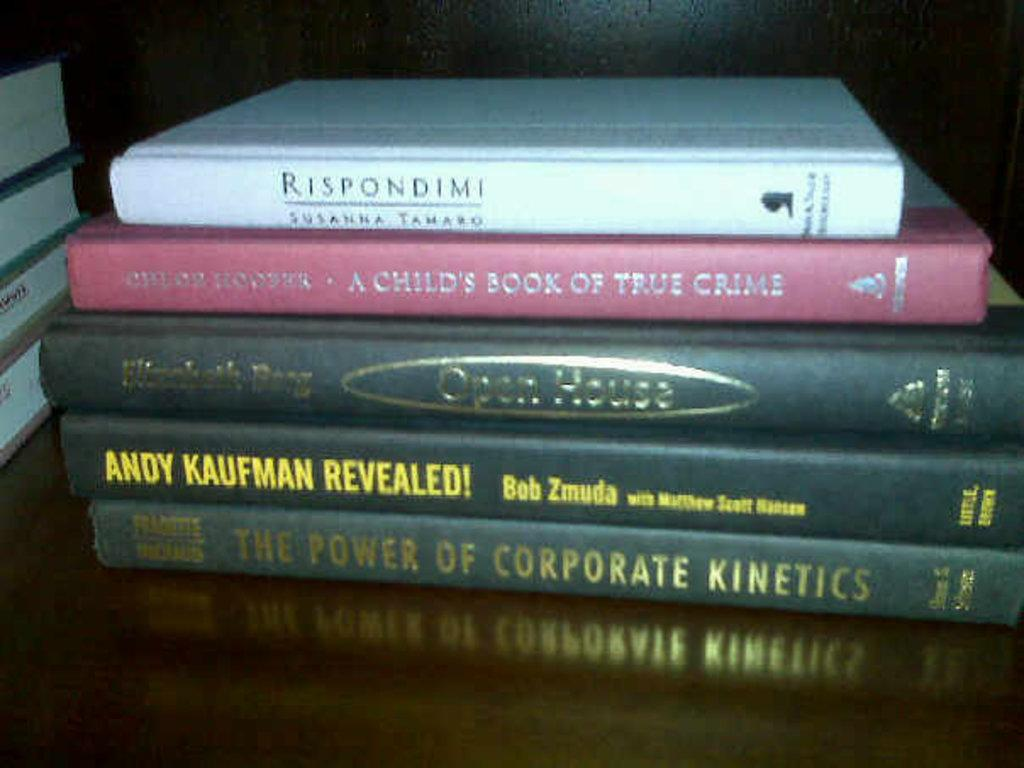<image>
Summarize the visual content of the image. A book called "Andy Kaufman Revealed" is in a stack of other books on a table 